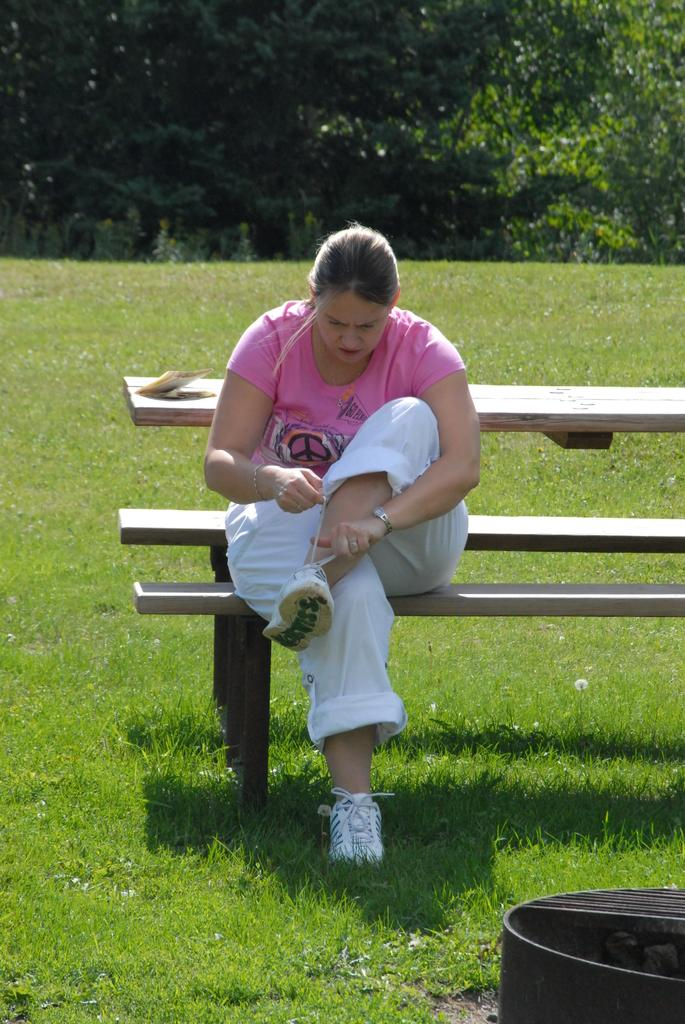Who is the main subject in the image? There is a woman in the image. What is the woman doing in the image? The woman is sitting on a bench and tying her shoe lace. What is the woman wearing in the image? The woman is wearing a pink t-shirt and white trousers. What can be seen in the background of the image? There are trees visible in the background of the image. Is there a sink visible in the image? No, there is no sink present in the image. Is the woman surrounded by snow in the image? No, there is no snow present in the image. 